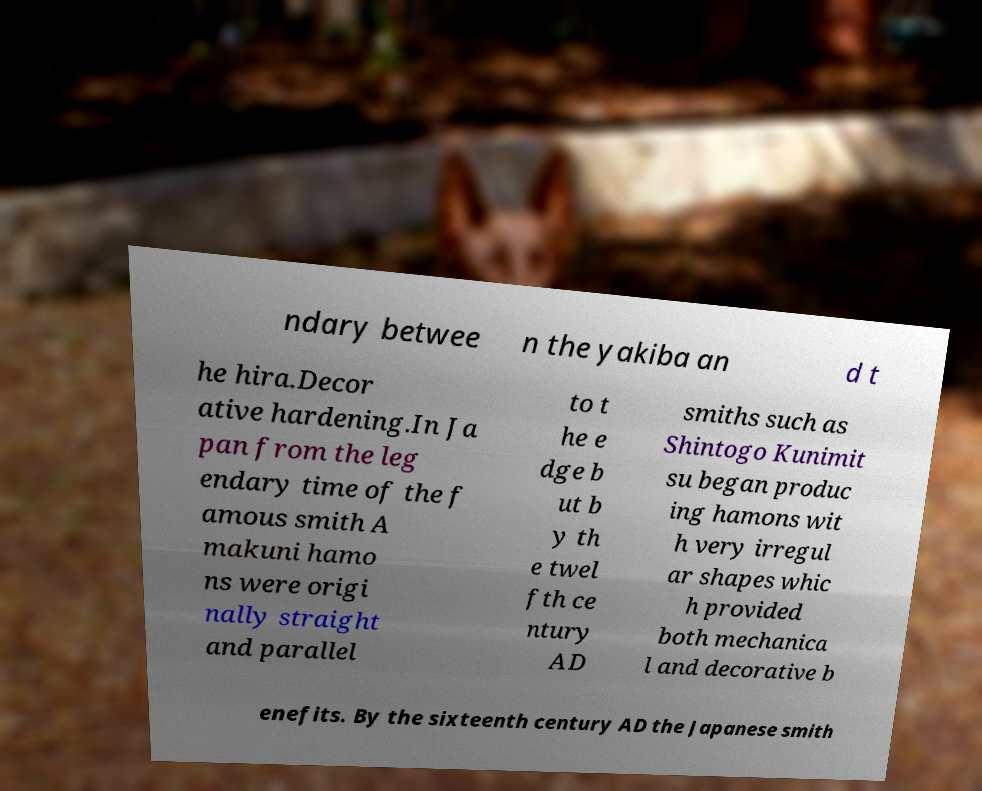What messages or text are displayed in this image? I need them in a readable, typed format. ndary betwee n the yakiba an d t he hira.Decor ative hardening.In Ja pan from the leg endary time of the f amous smith A makuni hamo ns were origi nally straight and parallel to t he e dge b ut b y th e twel fth ce ntury AD smiths such as Shintogo Kunimit su began produc ing hamons wit h very irregul ar shapes whic h provided both mechanica l and decorative b enefits. By the sixteenth century AD the Japanese smith 